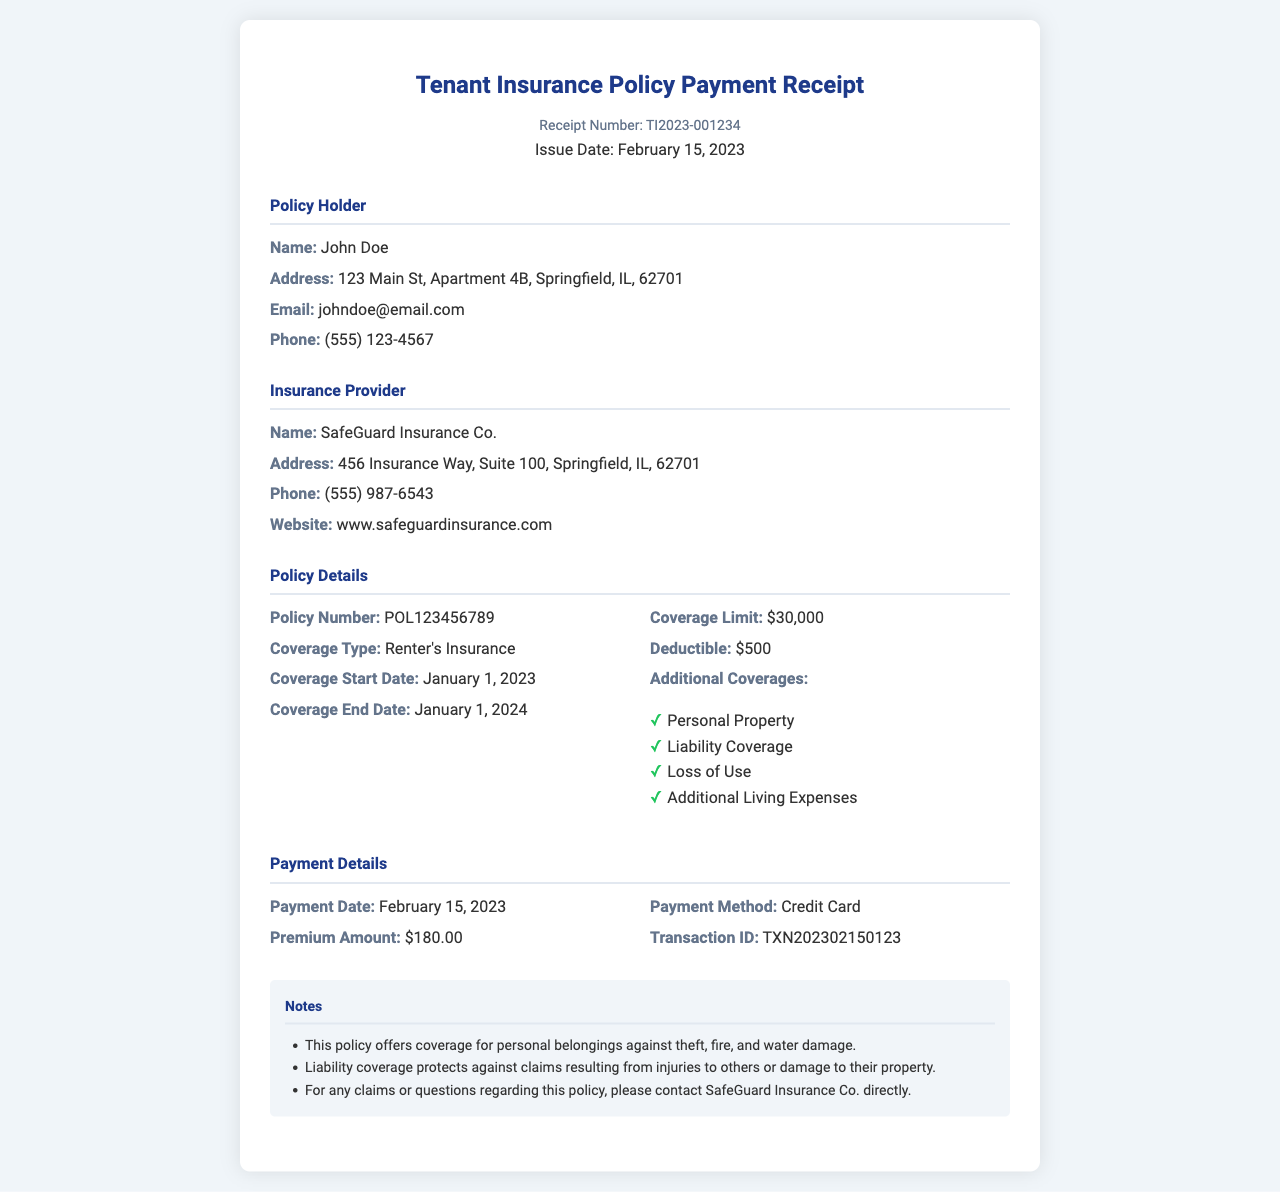What is the name of the policy holder? The name of the policy holder is listed in the document under "Policy Holder" section.
Answer: John Doe What is the premium amount for the year 2023? The premium amount is specified in the "Payment Details" section.
Answer: $180.00 When does the coverage start? The coverage start date is stated in the "Policy Details" section.
Answer: January 1, 2023 What is the deductible amount? The deductible amount is provided under "Policy Details".
Answer: $500 What is the coverage limit? The coverage limit is found in the "Policy Details" section.
Answer: $30,000 Who is the insurance provider? The insurance provider's name is located in the "Insurance Provider" section.
Answer: SafeGuard Insurance Co What method was used for payment? The payment method is indicated in the "Payment Details" section of the document.
Answer: Credit Card What is the transaction ID? The transaction ID can be found in the "Payment Details" section.
Answer: TXN202302150123 What additional coverage is offered? The additional coverage types are listed in the "Policy Details" section as a bulleted list.
Answer: Personal Property, Liability Coverage, Loss of Use, Additional Living Expenses 